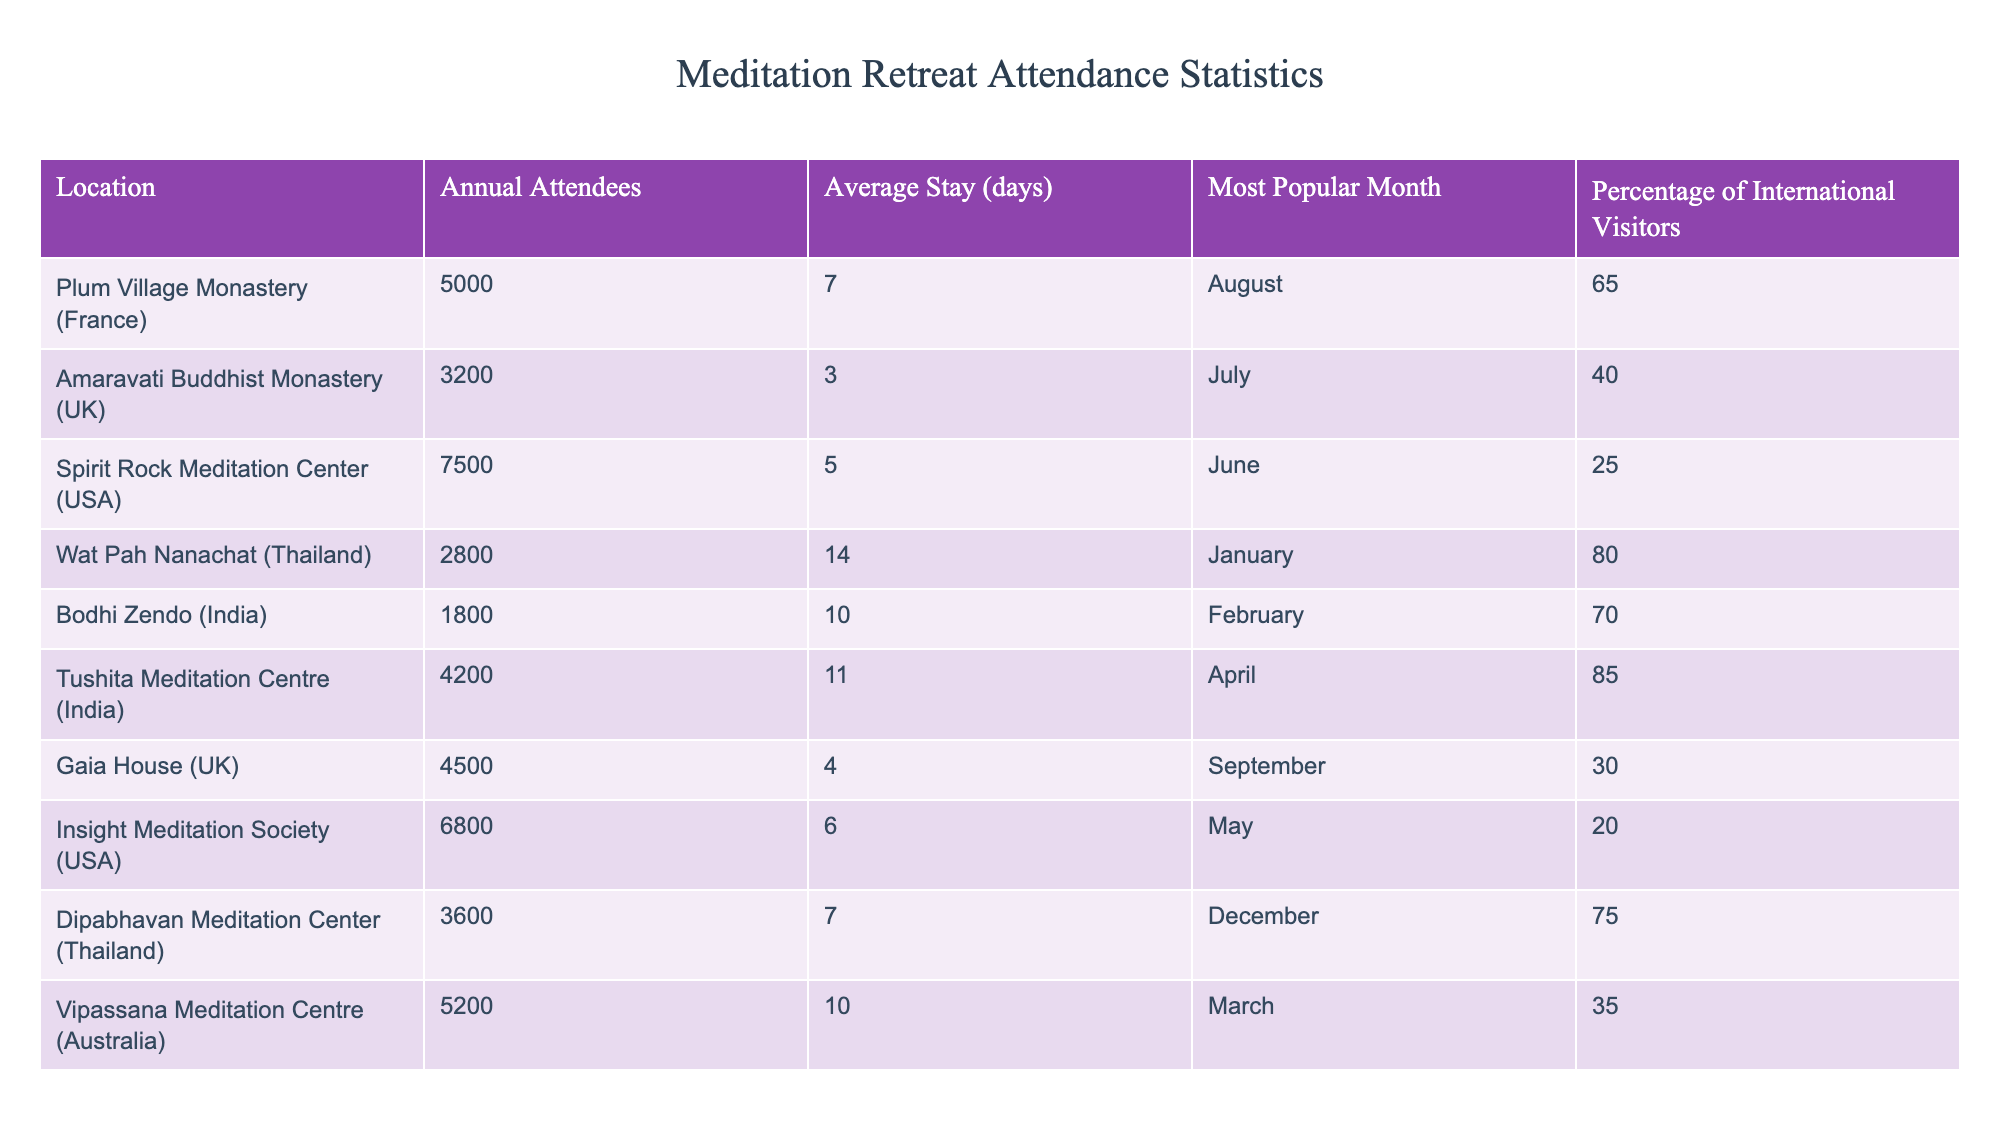What is the average stay duration at Tushita Meditation Centre? The average stay duration at Tushita Meditation Centre is listed in the table under the "Average Stay (days)" column. The value for Tushita Meditation Centre is 11 days.
Answer: 11 days Which location has the highest percentage of international visitors? By inspecting the "Percentage of International Visitors" column, Tushita Meditation Centre has the highest value at 85%.
Answer: Tushita Meditation Centre What is the total number of annual attendees from both UK locations? First, we identify the two UK locations: Amaravati Buddhist Monastery (3200 attendees) and Gaia House (4500 attendees). Adding these gives us 3200 + 4500 = 7700.
Answer: 7700 How many days do attendees at Wat Pah Nanachat typically stay? The average stay for attendees at Wat Pah Nanachat is recorded under the "Average Stay (days)" column, which states it is 14 days.
Answer: 14 days Is the average stay longer at Bodhi Zendo or Spirit Rock Meditation Center? Bodhi Zendo has an average stay of 10 days, while Spirit Rock Meditation Center has an average stay of 5 days. Since 10 is greater than 5, Bodhi Zendo has a longer average stay.
Answer: Bodhi Zendo What is the difference in the number of annual attendees between Plum Village Monastery and Insight Meditation Society? Plum Village Monastery has 5000 attendees and Insight Meditation Society has 6800 attendees. The difference is 6800 - 5000 = 1800 attendees.
Answer: 1800 attendees Are there any locations where the percentage of international visitors is above 75%? Yes, Tushita Meditation Centre (85%) and Wat Pah Nanachat (80%) both have percentages above 75%.
Answer: Yes Which month is the most popular for attendance at Tushita Meditation Centre? The "Most Popular Month" column indicates that the most popular month for Tushita Meditation Centre is April.
Answer: April How many locations have an average stay of more than 10 days? Looking at the "Average Stay (days)" column, we find Wat Pah Nanachat (14 days), Bodhi Zendo (10 days), and Tushita Meditation Centre (11 days). Only Wat Pah Nanachat (14 days) exceeds 10 days.
Answer: 1 location 